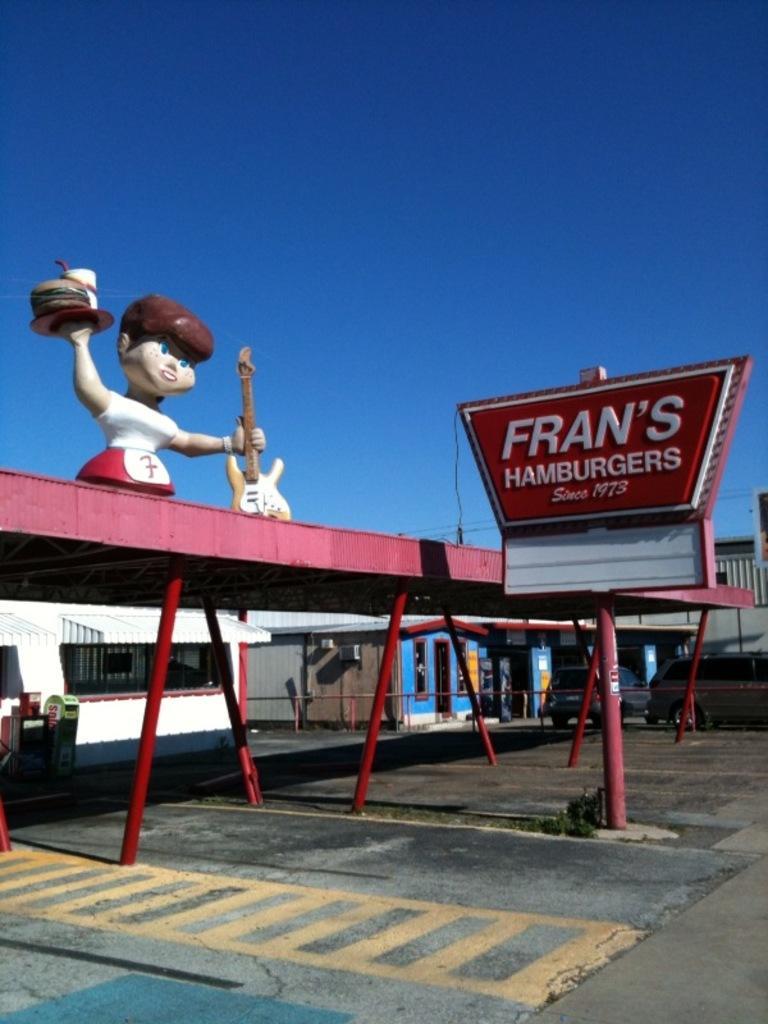Can you describe this image briefly? In the picture we can see a path with some yellow colored lines on it and on it we can see some red color poles with a stand on it, we can see a doll holding a guitar and beside it, we can see a board and written on it France hamburgers and behind we can see some houses and some cars are parked near it and behind it we can see a sky which is blue in color. 